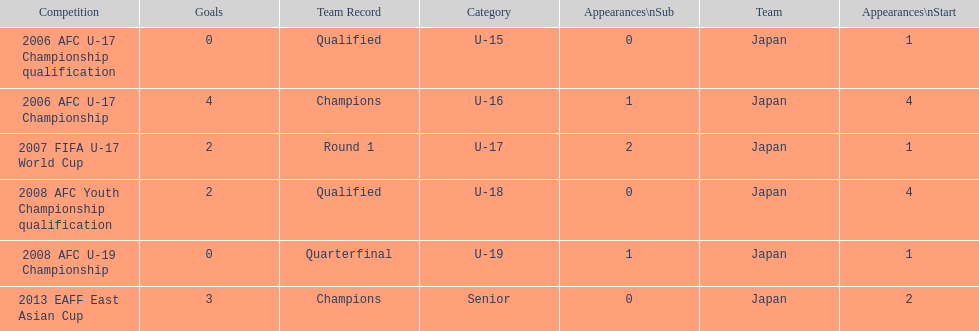In which two competitions did japan lack goals? 2006 AFC U-17 Championship qualification, 2008 AFC U-19 Championship. 